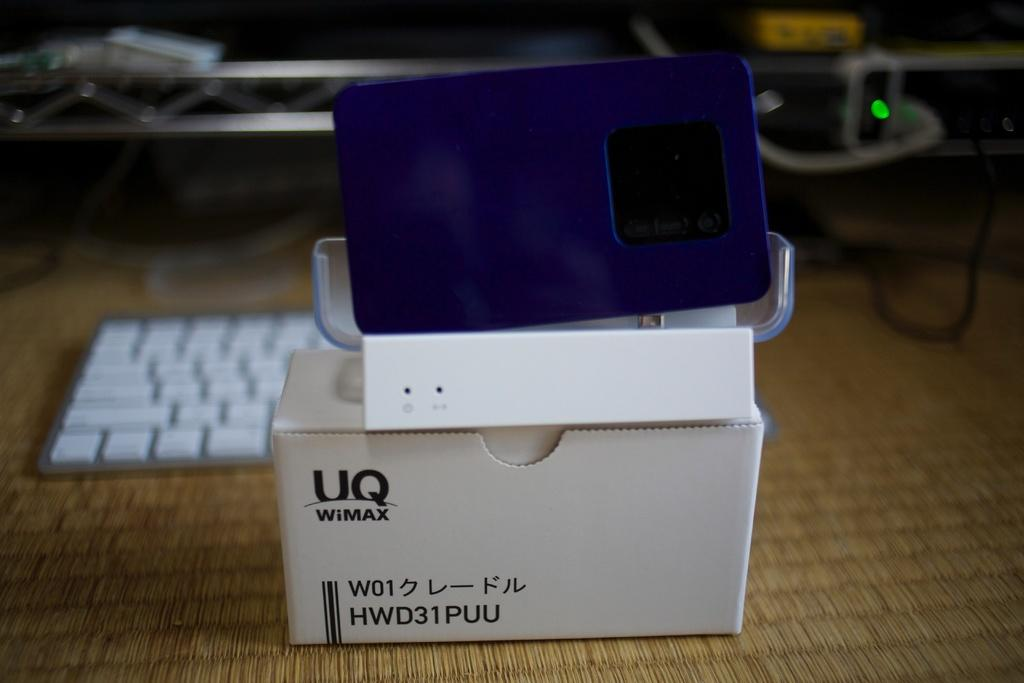<image>
Present a compact description of the photo's key features. A white box has a UQ WiMAX logo in the corner. 